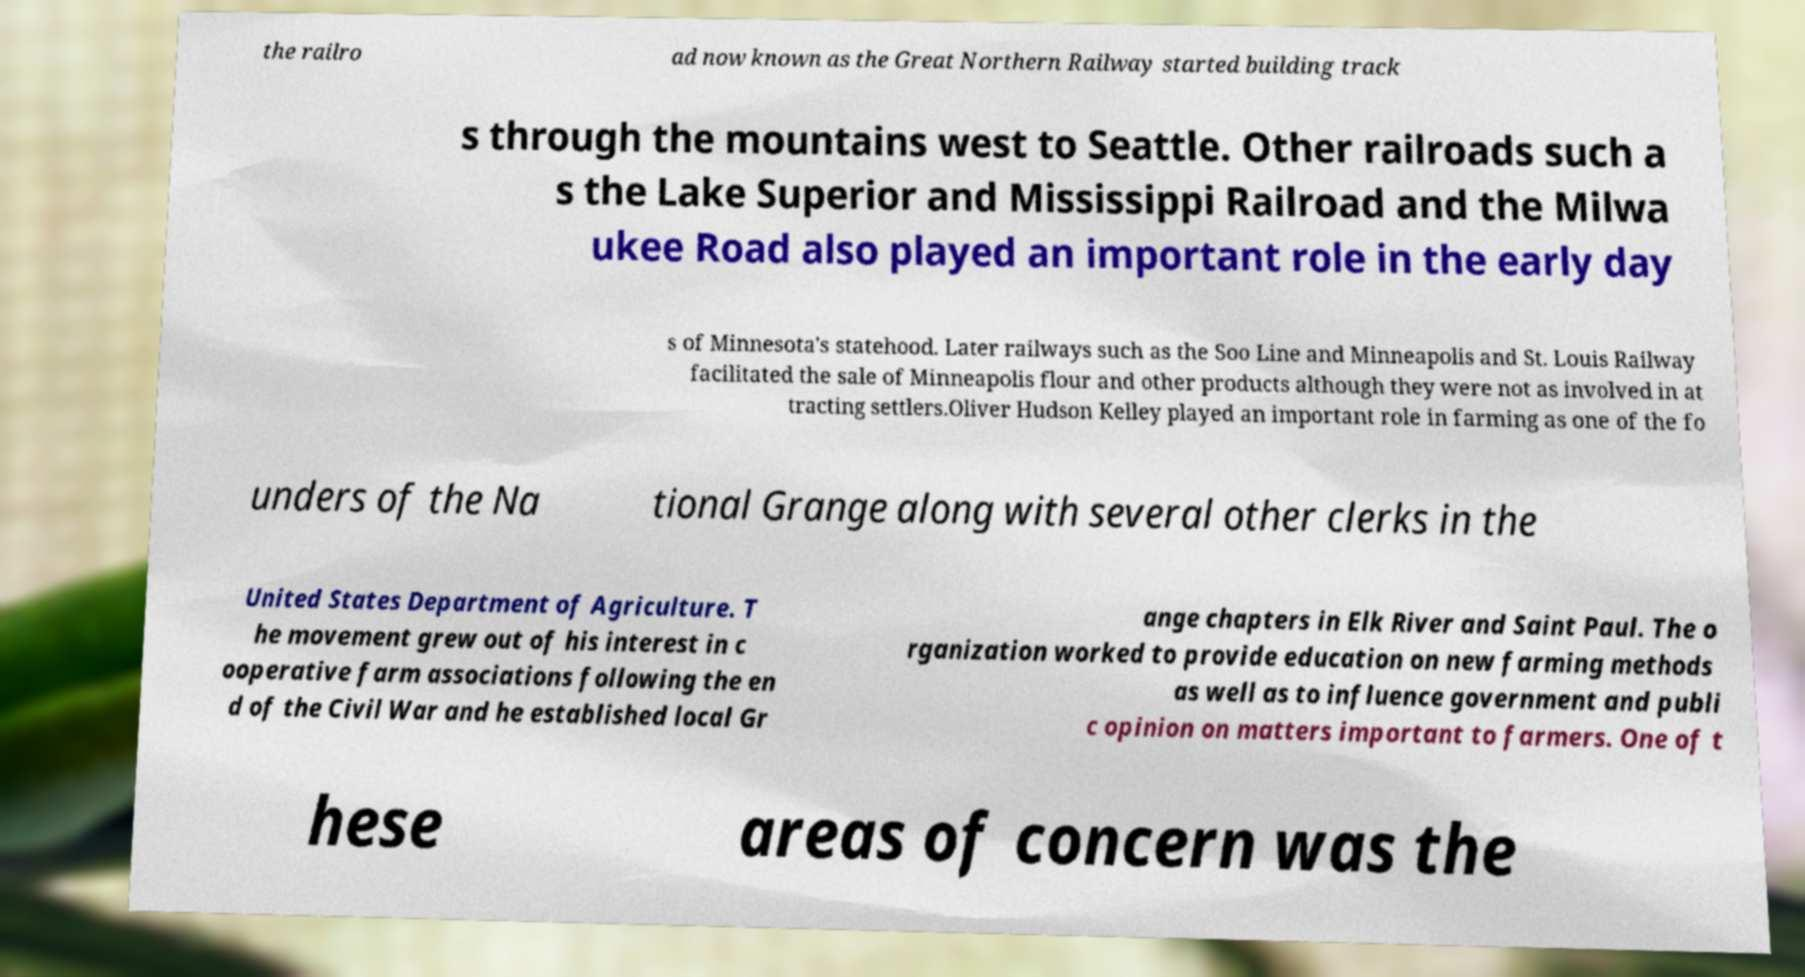Could you assist in decoding the text presented in this image and type it out clearly? the railro ad now known as the Great Northern Railway started building track s through the mountains west to Seattle. Other railroads such a s the Lake Superior and Mississippi Railroad and the Milwa ukee Road also played an important role in the early day s of Minnesota's statehood. Later railways such as the Soo Line and Minneapolis and St. Louis Railway facilitated the sale of Minneapolis flour and other products although they were not as involved in at tracting settlers.Oliver Hudson Kelley played an important role in farming as one of the fo unders of the Na tional Grange along with several other clerks in the United States Department of Agriculture. T he movement grew out of his interest in c ooperative farm associations following the en d of the Civil War and he established local Gr ange chapters in Elk River and Saint Paul. The o rganization worked to provide education on new farming methods as well as to influence government and publi c opinion on matters important to farmers. One of t hese areas of concern was the 